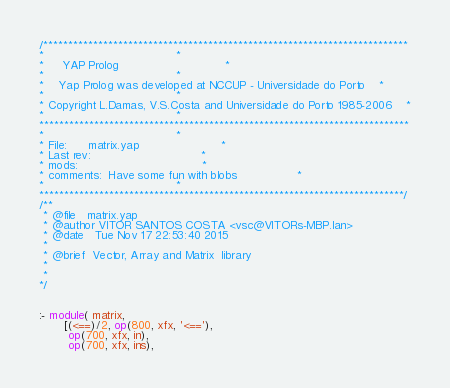Convert code to text. <code><loc_0><loc_0><loc_500><loc_500><_Prolog_>/*************************************************************************
*									 *
*	 YAP Prolog 							 *
*									 *
*	Yap Prolog was developed at NCCUP - Universidade do Porto	 *
*									 *
* Copyright L.Damas, V.S.Costa and Universidade do Porto 1985-2006	 *
*									 *
**************************************************************************
*									 *
* File:		matrix.yap						 *
* Last rev:								 *
* mods:									 *
* comments:	Have some fun with blobs				 *
*									 *
*************************************************************************/
/**
 * @file   matrix.yap
 * @author VITOR SANTOS COSTA <vsc@VITORs-MBP.lan>
 * @date   Tue Nov 17 22:53:40 2015
 * 
 * @brief  Vector, Array and Matrix  library
 * 
 * 
*/


:- module( matrix,
	   [(<==)/2, op(800, xfx, '<=='),
	    op(700, xfx, in),
	    op(700, xfx, ins),</code> 